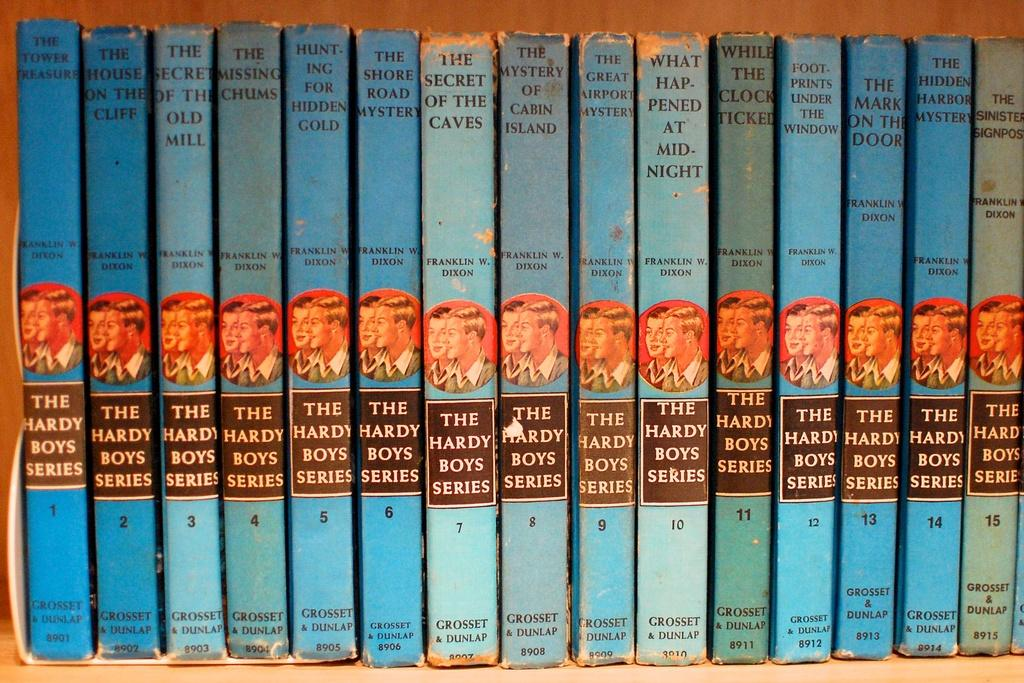<image>
Present a compact description of the photo's key features. fifteen different volumes of the hardy boys series by grosset and dunlap. 